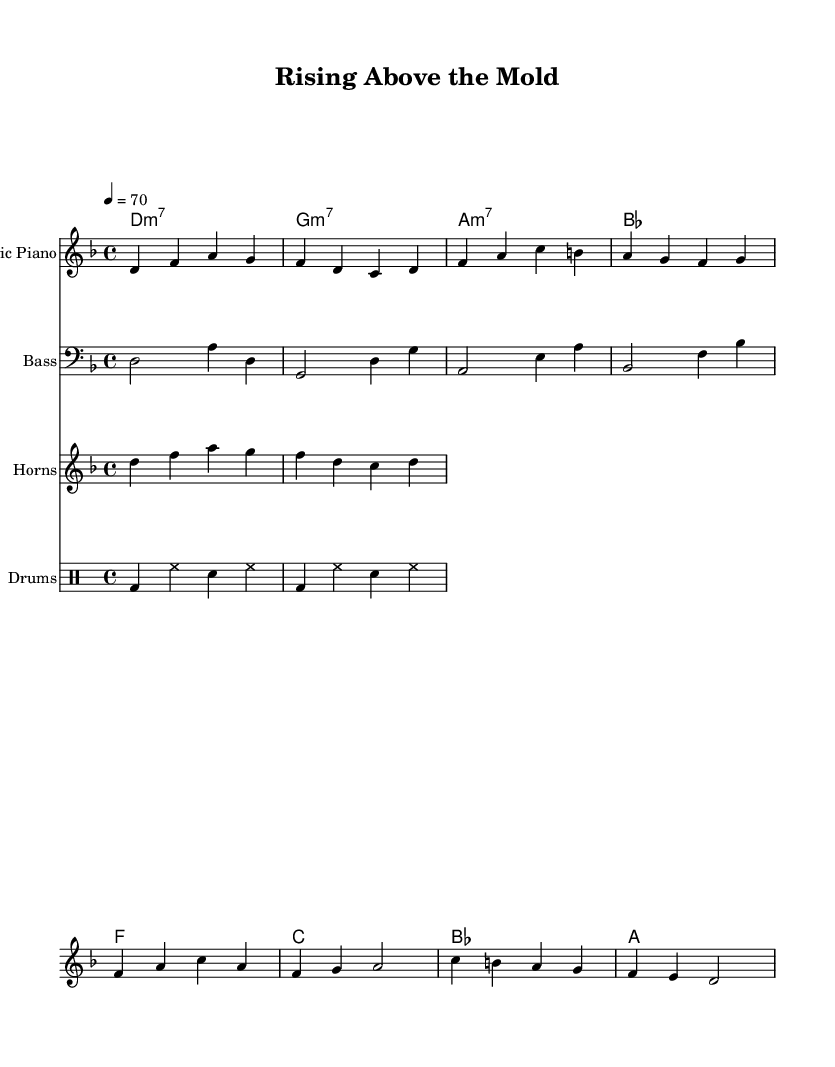What is the key signature of this music? The key signature is D minor, which has one flat (B flat). This can be found in the global section of the code where it specifies `\key d \minor`.
Answer: D minor What is the time signature of this music? The time signature is 4/4, which indicates there are four beats in each measure. This is stated in the global settings of the code with `\time 4/4`.
Answer: 4/4 What is the tempo marking for this piece? The tempo marking is 70 beats per minute, indicated by `\tempo 4 = 70` in the global section. This specifies the speed at which the music should be played.
Answer: 70 How many measures are there in the verse? There are four measures in the verse as each line contributes to one measure, and the lyrics indicate a total of four phrases that match the measures in the music.
Answer: Four What style of music does this piece represent? The piece represents Funk music, characterized by its rhythmic groove and soulful melodies. This is derived from the style and structure of the song, which includes soulful ballads and personal narratives.
Answer: Funk 